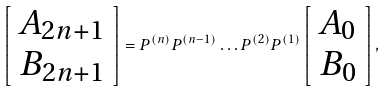Convert formula to latex. <formula><loc_0><loc_0><loc_500><loc_500>\left [ \begin{array} { c } A _ { 2 n + 1 } \\ B _ { 2 n + 1 } \end{array} \right ] = P ^ { ( n ) } P ^ { ( n - 1 ) } \dots P ^ { ( 2 ) } P ^ { ( 1 ) } \left [ \begin{array} { c } A _ { 0 } \\ B _ { 0 } \end{array} \right ] ,</formula> 